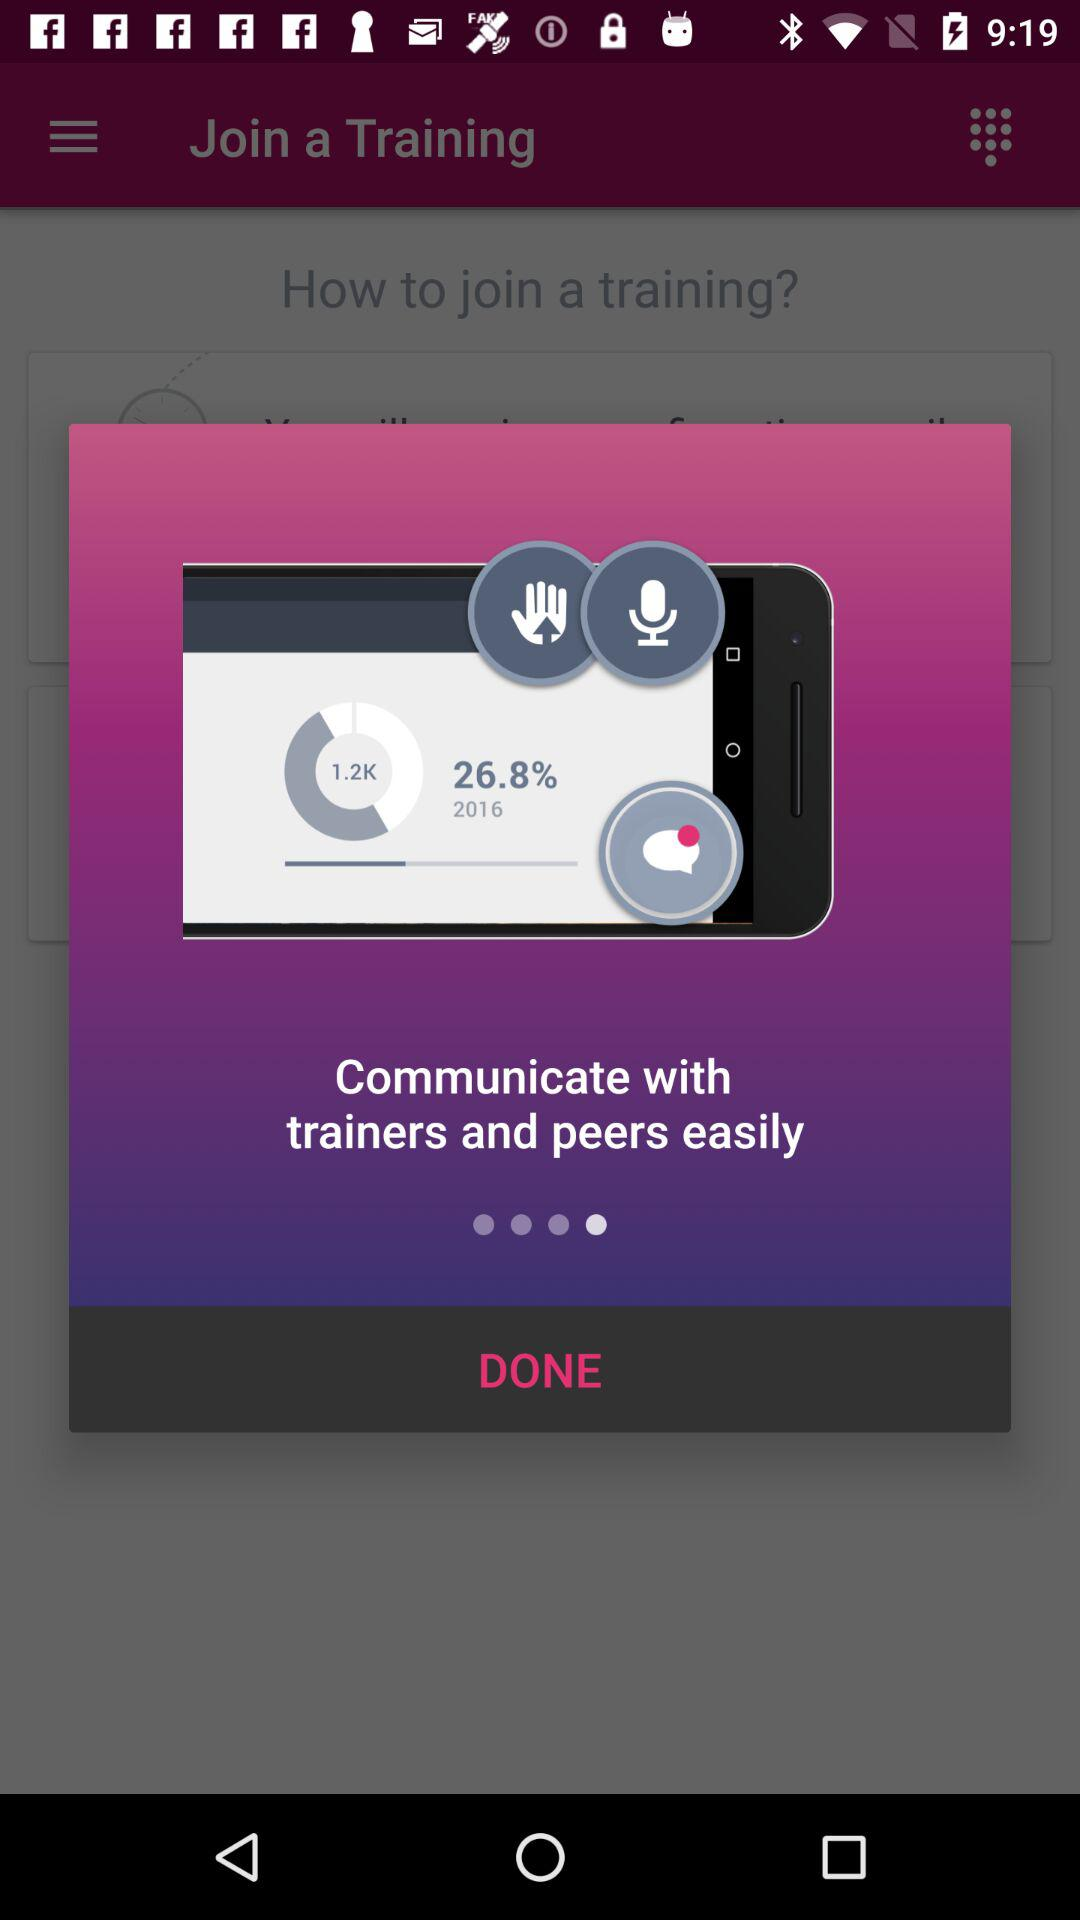What is the size of the file?
When the provided information is insufficient, respond with <no answer>. <no answer> 